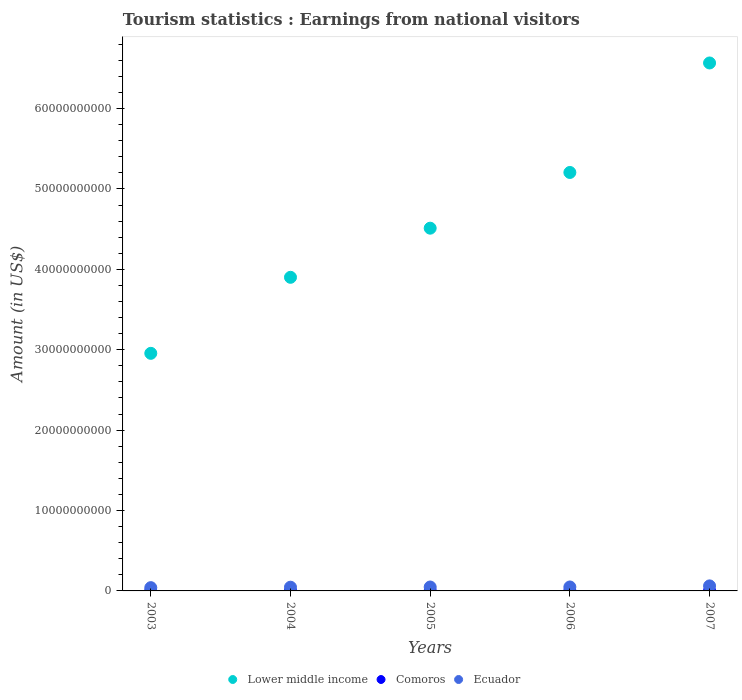How many different coloured dotlines are there?
Offer a very short reply. 3. Is the number of dotlines equal to the number of legend labels?
Provide a succinct answer. Yes. What is the earnings from national visitors in Comoros in 2005?
Keep it short and to the point. 2.44e+07. Across all years, what is the maximum earnings from national visitors in Comoros?
Offer a terse response. 3.04e+07. Across all years, what is the minimum earnings from national visitors in Ecuador?
Your answer should be compact. 4.08e+08. What is the total earnings from national visitors in Comoros in the graph?
Keep it short and to the point. 1.19e+08. What is the difference between the earnings from national visitors in Ecuador in 2004 and that in 2007?
Your answer should be very brief. -1.62e+08. What is the difference between the earnings from national visitors in Comoros in 2006 and the earnings from national visitors in Lower middle income in 2004?
Provide a short and direct response. -3.90e+1. What is the average earnings from national visitors in Lower middle income per year?
Keep it short and to the point. 4.63e+1. In the year 2005, what is the difference between the earnings from national visitors in Ecuador and earnings from national visitors in Lower middle income?
Ensure brevity in your answer.  -4.46e+1. What is the ratio of the earnings from national visitors in Comoros in 2003 to that in 2004?
Your response must be concise. 0.76. Is the earnings from national visitors in Comoros in 2003 less than that in 2006?
Provide a short and direct response. Yes. What is the difference between the highest and the second highest earnings from national visitors in Comoros?
Provide a short and direct response. 3.00e+06. What is the difference between the highest and the lowest earnings from national visitors in Lower middle income?
Ensure brevity in your answer.  3.61e+1. Is the sum of the earnings from national visitors in Ecuador in 2003 and 2004 greater than the maximum earnings from national visitors in Lower middle income across all years?
Make the answer very short. No. Is the earnings from national visitors in Lower middle income strictly less than the earnings from national visitors in Comoros over the years?
Ensure brevity in your answer.  No. How many dotlines are there?
Provide a succinct answer. 3. How many years are there in the graph?
Make the answer very short. 5. What is the difference between two consecutive major ticks on the Y-axis?
Give a very brief answer. 1.00e+1. Are the values on the major ticks of Y-axis written in scientific E-notation?
Keep it short and to the point. No. Does the graph contain any zero values?
Keep it short and to the point. No. Where does the legend appear in the graph?
Give a very brief answer. Bottom center. How are the legend labels stacked?
Offer a terse response. Horizontal. What is the title of the graph?
Ensure brevity in your answer.  Tourism statistics : Earnings from national visitors. What is the label or title of the Y-axis?
Your answer should be very brief. Amount (in US$). What is the Amount (in US$) of Lower middle income in 2003?
Ensure brevity in your answer.  2.96e+1. What is the Amount (in US$) in Comoros in 2003?
Keep it short and to the point. 1.60e+07. What is the Amount (in US$) in Ecuador in 2003?
Make the answer very short. 4.08e+08. What is the Amount (in US$) in Lower middle income in 2004?
Offer a terse response. 3.90e+1. What is the Amount (in US$) of Comoros in 2004?
Give a very brief answer. 2.10e+07. What is the Amount (in US$) in Ecuador in 2004?
Give a very brief answer. 4.64e+08. What is the Amount (in US$) of Lower middle income in 2005?
Ensure brevity in your answer.  4.51e+1. What is the Amount (in US$) in Comoros in 2005?
Offer a terse response. 2.44e+07. What is the Amount (in US$) in Ecuador in 2005?
Offer a terse response. 4.88e+08. What is the Amount (in US$) in Lower middle income in 2006?
Keep it short and to the point. 5.21e+1. What is the Amount (in US$) of Comoros in 2006?
Give a very brief answer. 2.74e+07. What is the Amount (in US$) in Ecuador in 2006?
Your answer should be very brief. 4.92e+08. What is the Amount (in US$) of Lower middle income in 2007?
Ensure brevity in your answer.  6.57e+1. What is the Amount (in US$) in Comoros in 2007?
Your response must be concise. 3.04e+07. What is the Amount (in US$) of Ecuador in 2007?
Keep it short and to the point. 6.26e+08. Across all years, what is the maximum Amount (in US$) of Lower middle income?
Provide a succinct answer. 6.57e+1. Across all years, what is the maximum Amount (in US$) in Comoros?
Your answer should be very brief. 3.04e+07. Across all years, what is the maximum Amount (in US$) of Ecuador?
Your response must be concise. 6.26e+08. Across all years, what is the minimum Amount (in US$) of Lower middle income?
Your answer should be very brief. 2.96e+1. Across all years, what is the minimum Amount (in US$) of Comoros?
Your answer should be very brief. 1.60e+07. Across all years, what is the minimum Amount (in US$) in Ecuador?
Provide a short and direct response. 4.08e+08. What is the total Amount (in US$) in Lower middle income in the graph?
Provide a succinct answer. 2.31e+11. What is the total Amount (in US$) in Comoros in the graph?
Your answer should be very brief. 1.19e+08. What is the total Amount (in US$) of Ecuador in the graph?
Keep it short and to the point. 2.48e+09. What is the difference between the Amount (in US$) in Lower middle income in 2003 and that in 2004?
Make the answer very short. -9.46e+09. What is the difference between the Amount (in US$) in Comoros in 2003 and that in 2004?
Provide a succinct answer. -5.00e+06. What is the difference between the Amount (in US$) of Ecuador in 2003 and that in 2004?
Your answer should be very brief. -5.60e+07. What is the difference between the Amount (in US$) of Lower middle income in 2003 and that in 2005?
Offer a terse response. -1.56e+1. What is the difference between the Amount (in US$) of Comoros in 2003 and that in 2005?
Keep it short and to the point. -8.40e+06. What is the difference between the Amount (in US$) of Ecuador in 2003 and that in 2005?
Give a very brief answer. -8.00e+07. What is the difference between the Amount (in US$) of Lower middle income in 2003 and that in 2006?
Offer a terse response. -2.25e+1. What is the difference between the Amount (in US$) of Comoros in 2003 and that in 2006?
Ensure brevity in your answer.  -1.14e+07. What is the difference between the Amount (in US$) in Ecuador in 2003 and that in 2006?
Make the answer very short. -8.40e+07. What is the difference between the Amount (in US$) of Lower middle income in 2003 and that in 2007?
Your answer should be very brief. -3.61e+1. What is the difference between the Amount (in US$) in Comoros in 2003 and that in 2007?
Your response must be concise. -1.44e+07. What is the difference between the Amount (in US$) in Ecuador in 2003 and that in 2007?
Offer a very short reply. -2.18e+08. What is the difference between the Amount (in US$) in Lower middle income in 2004 and that in 2005?
Offer a very short reply. -6.11e+09. What is the difference between the Amount (in US$) in Comoros in 2004 and that in 2005?
Give a very brief answer. -3.40e+06. What is the difference between the Amount (in US$) in Ecuador in 2004 and that in 2005?
Your answer should be compact. -2.40e+07. What is the difference between the Amount (in US$) of Lower middle income in 2004 and that in 2006?
Offer a very short reply. -1.30e+1. What is the difference between the Amount (in US$) of Comoros in 2004 and that in 2006?
Offer a terse response. -6.40e+06. What is the difference between the Amount (in US$) in Ecuador in 2004 and that in 2006?
Your answer should be very brief. -2.80e+07. What is the difference between the Amount (in US$) of Lower middle income in 2004 and that in 2007?
Ensure brevity in your answer.  -2.67e+1. What is the difference between the Amount (in US$) of Comoros in 2004 and that in 2007?
Provide a succinct answer. -9.40e+06. What is the difference between the Amount (in US$) in Ecuador in 2004 and that in 2007?
Offer a terse response. -1.62e+08. What is the difference between the Amount (in US$) in Lower middle income in 2005 and that in 2006?
Make the answer very short. -6.93e+09. What is the difference between the Amount (in US$) in Comoros in 2005 and that in 2006?
Offer a terse response. -3.00e+06. What is the difference between the Amount (in US$) of Ecuador in 2005 and that in 2006?
Provide a succinct answer. -4.00e+06. What is the difference between the Amount (in US$) in Lower middle income in 2005 and that in 2007?
Provide a short and direct response. -2.06e+1. What is the difference between the Amount (in US$) in Comoros in 2005 and that in 2007?
Your answer should be very brief. -6.00e+06. What is the difference between the Amount (in US$) of Ecuador in 2005 and that in 2007?
Your answer should be compact. -1.38e+08. What is the difference between the Amount (in US$) of Lower middle income in 2006 and that in 2007?
Ensure brevity in your answer.  -1.36e+1. What is the difference between the Amount (in US$) of Comoros in 2006 and that in 2007?
Give a very brief answer. -3.00e+06. What is the difference between the Amount (in US$) in Ecuador in 2006 and that in 2007?
Provide a succinct answer. -1.34e+08. What is the difference between the Amount (in US$) in Lower middle income in 2003 and the Amount (in US$) in Comoros in 2004?
Keep it short and to the point. 2.95e+1. What is the difference between the Amount (in US$) in Lower middle income in 2003 and the Amount (in US$) in Ecuador in 2004?
Provide a succinct answer. 2.91e+1. What is the difference between the Amount (in US$) in Comoros in 2003 and the Amount (in US$) in Ecuador in 2004?
Ensure brevity in your answer.  -4.48e+08. What is the difference between the Amount (in US$) of Lower middle income in 2003 and the Amount (in US$) of Comoros in 2005?
Give a very brief answer. 2.95e+1. What is the difference between the Amount (in US$) in Lower middle income in 2003 and the Amount (in US$) in Ecuador in 2005?
Keep it short and to the point. 2.91e+1. What is the difference between the Amount (in US$) of Comoros in 2003 and the Amount (in US$) of Ecuador in 2005?
Give a very brief answer. -4.72e+08. What is the difference between the Amount (in US$) of Lower middle income in 2003 and the Amount (in US$) of Comoros in 2006?
Keep it short and to the point. 2.95e+1. What is the difference between the Amount (in US$) in Lower middle income in 2003 and the Amount (in US$) in Ecuador in 2006?
Ensure brevity in your answer.  2.91e+1. What is the difference between the Amount (in US$) of Comoros in 2003 and the Amount (in US$) of Ecuador in 2006?
Provide a succinct answer. -4.76e+08. What is the difference between the Amount (in US$) of Lower middle income in 2003 and the Amount (in US$) of Comoros in 2007?
Give a very brief answer. 2.95e+1. What is the difference between the Amount (in US$) in Lower middle income in 2003 and the Amount (in US$) in Ecuador in 2007?
Offer a very short reply. 2.89e+1. What is the difference between the Amount (in US$) of Comoros in 2003 and the Amount (in US$) of Ecuador in 2007?
Offer a terse response. -6.10e+08. What is the difference between the Amount (in US$) in Lower middle income in 2004 and the Amount (in US$) in Comoros in 2005?
Your answer should be very brief. 3.90e+1. What is the difference between the Amount (in US$) of Lower middle income in 2004 and the Amount (in US$) of Ecuador in 2005?
Ensure brevity in your answer.  3.85e+1. What is the difference between the Amount (in US$) in Comoros in 2004 and the Amount (in US$) in Ecuador in 2005?
Provide a short and direct response. -4.67e+08. What is the difference between the Amount (in US$) in Lower middle income in 2004 and the Amount (in US$) in Comoros in 2006?
Your response must be concise. 3.90e+1. What is the difference between the Amount (in US$) of Lower middle income in 2004 and the Amount (in US$) of Ecuador in 2006?
Offer a terse response. 3.85e+1. What is the difference between the Amount (in US$) of Comoros in 2004 and the Amount (in US$) of Ecuador in 2006?
Offer a very short reply. -4.71e+08. What is the difference between the Amount (in US$) in Lower middle income in 2004 and the Amount (in US$) in Comoros in 2007?
Ensure brevity in your answer.  3.90e+1. What is the difference between the Amount (in US$) of Lower middle income in 2004 and the Amount (in US$) of Ecuador in 2007?
Provide a succinct answer. 3.84e+1. What is the difference between the Amount (in US$) of Comoros in 2004 and the Amount (in US$) of Ecuador in 2007?
Your response must be concise. -6.05e+08. What is the difference between the Amount (in US$) of Lower middle income in 2005 and the Amount (in US$) of Comoros in 2006?
Provide a short and direct response. 4.51e+1. What is the difference between the Amount (in US$) of Lower middle income in 2005 and the Amount (in US$) of Ecuador in 2006?
Provide a short and direct response. 4.46e+1. What is the difference between the Amount (in US$) of Comoros in 2005 and the Amount (in US$) of Ecuador in 2006?
Offer a terse response. -4.68e+08. What is the difference between the Amount (in US$) of Lower middle income in 2005 and the Amount (in US$) of Comoros in 2007?
Your answer should be very brief. 4.51e+1. What is the difference between the Amount (in US$) in Lower middle income in 2005 and the Amount (in US$) in Ecuador in 2007?
Offer a terse response. 4.45e+1. What is the difference between the Amount (in US$) of Comoros in 2005 and the Amount (in US$) of Ecuador in 2007?
Your response must be concise. -6.02e+08. What is the difference between the Amount (in US$) of Lower middle income in 2006 and the Amount (in US$) of Comoros in 2007?
Your response must be concise. 5.20e+1. What is the difference between the Amount (in US$) in Lower middle income in 2006 and the Amount (in US$) in Ecuador in 2007?
Ensure brevity in your answer.  5.14e+1. What is the difference between the Amount (in US$) of Comoros in 2006 and the Amount (in US$) of Ecuador in 2007?
Offer a very short reply. -5.99e+08. What is the average Amount (in US$) in Lower middle income per year?
Offer a very short reply. 4.63e+1. What is the average Amount (in US$) in Comoros per year?
Your response must be concise. 2.38e+07. What is the average Amount (in US$) of Ecuador per year?
Your response must be concise. 4.96e+08. In the year 2003, what is the difference between the Amount (in US$) of Lower middle income and Amount (in US$) of Comoros?
Give a very brief answer. 2.95e+1. In the year 2003, what is the difference between the Amount (in US$) in Lower middle income and Amount (in US$) in Ecuador?
Your answer should be very brief. 2.91e+1. In the year 2003, what is the difference between the Amount (in US$) of Comoros and Amount (in US$) of Ecuador?
Give a very brief answer. -3.92e+08. In the year 2004, what is the difference between the Amount (in US$) in Lower middle income and Amount (in US$) in Comoros?
Give a very brief answer. 3.90e+1. In the year 2004, what is the difference between the Amount (in US$) of Lower middle income and Amount (in US$) of Ecuador?
Ensure brevity in your answer.  3.86e+1. In the year 2004, what is the difference between the Amount (in US$) of Comoros and Amount (in US$) of Ecuador?
Provide a short and direct response. -4.43e+08. In the year 2005, what is the difference between the Amount (in US$) in Lower middle income and Amount (in US$) in Comoros?
Provide a short and direct response. 4.51e+1. In the year 2005, what is the difference between the Amount (in US$) of Lower middle income and Amount (in US$) of Ecuador?
Offer a terse response. 4.46e+1. In the year 2005, what is the difference between the Amount (in US$) of Comoros and Amount (in US$) of Ecuador?
Offer a very short reply. -4.64e+08. In the year 2006, what is the difference between the Amount (in US$) of Lower middle income and Amount (in US$) of Comoros?
Provide a short and direct response. 5.20e+1. In the year 2006, what is the difference between the Amount (in US$) of Lower middle income and Amount (in US$) of Ecuador?
Give a very brief answer. 5.16e+1. In the year 2006, what is the difference between the Amount (in US$) in Comoros and Amount (in US$) in Ecuador?
Provide a succinct answer. -4.65e+08. In the year 2007, what is the difference between the Amount (in US$) of Lower middle income and Amount (in US$) of Comoros?
Your answer should be compact. 6.56e+1. In the year 2007, what is the difference between the Amount (in US$) of Lower middle income and Amount (in US$) of Ecuador?
Ensure brevity in your answer.  6.51e+1. In the year 2007, what is the difference between the Amount (in US$) in Comoros and Amount (in US$) in Ecuador?
Your answer should be very brief. -5.96e+08. What is the ratio of the Amount (in US$) in Lower middle income in 2003 to that in 2004?
Provide a short and direct response. 0.76. What is the ratio of the Amount (in US$) of Comoros in 2003 to that in 2004?
Offer a very short reply. 0.76. What is the ratio of the Amount (in US$) of Ecuador in 2003 to that in 2004?
Ensure brevity in your answer.  0.88. What is the ratio of the Amount (in US$) in Lower middle income in 2003 to that in 2005?
Provide a succinct answer. 0.66. What is the ratio of the Amount (in US$) in Comoros in 2003 to that in 2005?
Keep it short and to the point. 0.66. What is the ratio of the Amount (in US$) in Ecuador in 2003 to that in 2005?
Provide a succinct answer. 0.84. What is the ratio of the Amount (in US$) of Lower middle income in 2003 to that in 2006?
Offer a terse response. 0.57. What is the ratio of the Amount (in US$) in Comoros in 2003 to that in 2006?
Make the answer very short. 0.58. What is the ratio of the Amount (in US$) in Ecuador in 2003 to that in 2006?
Provide a short and direct response. 0.83. What is the ratio of the Amount (in US$) in Lower middle income in 2003 to that in 2007?
Provide a succinct answer. 0.45. What is the ratio of the Amount (in US$) of Comoros in 2003 to that in 2007?
Offer a very short reply. 0.53. What is the ratio of the Amount (in US$) of Ecuador in 2003 to that in 2007?
Provide a succinct answer. 0.65. What is the ratio of the Amount (in US$) of Lower middle income in 2004 to that in 2005?
Provide a succinct answer. 0.86. What is the ratio of the Amount (in US$) in Comoros in 2004 to that in 2005?
Offer a terse response. 0.86. What is the ratio of the Amount (in US$) of Ecuador in 2004 to that in 2005?
Offer a very short reply. 0.95. What is the ratio of the Amount (in US$) in Lower middle income in 2004 to that in 2006?
Make the answer very short. 0.75. What is the ratio of the Amount (in US$) in Comoros in 2004 to that in 2006?
Make the answer very short. 0.77. What is the ratio of the Amount (in US$) in Ecuador in 2004 to that in 2006?
Make the answer very short. 0.94. What is the ratio of the Amount (in US$) of Lower middle income in 2004 to that in 2007?
Give a very brief answer. 0.59. What is the ratio of the Amount (in US$) in Comoros in 2004 to that in 2007?
Provide a succinct answer. 0.69. What is the ratio of the Amount (in US$) in Ecuador in 2004 to that in 2007?
Offer a very short reply. 0.74. What is the ratio of the Amount (in US$) of Lower middle income in 2005 to that in 2006?
Give a very brief answer. 0.87. What is the ratio of the Amount (in US$) in Comoros in 2005 to that in 2006?
Your response must be concise. 0.89. What is the ratio of the Amount (in US$) of Ecuador in 2005 to that in 2006?
Offer a terse response. 0.99. What is the ratio of the Amount (in US$) of Lower middle income in 2005 to that in 2007?
Your answer should be very brief. 0.69. What is the ratio of the Amount (in US$) of Comoros in 2005 to that in 2007?
Keep it short and to the point. 0.8. What is the ratio of the Amount (in US$) in Ecuador in 2005 to that in 2007?
Offer a terse response. 0.78. What is the ratio of the Amount (in US$) of Lower middle income in 2006 to that in 2007?
Offer a terse response. 0.79. What is the ratio of the Amount (in US$) of Comoros in 2006 to that in 2007?
Ensure brevity in your answer.  0.9. What is the ratio of the Amount (in US$) in Ecuador in 2006 to that in 2007?
Your answer should be very brief. 0.79. What is the difference between the highest and the second highest Amount (in US$) in Lower middle income?
Your answer should be very brief. 1.36e+1. What is the difference between the highest and the second highest Amount (in US$) of Comoros?
Ensure brevity in your answer.  3.00e+06. What is the difference between the highest and the second highest Amount (in US$) of Ecuador?
Your answer should be very brief. 1.34e+08. What is the difference between the highest and the lowest Amount (in US$) of Lower middle income?
Give a very brief answer. 3.61e+1. What is the difference between the highest and the lowest Amount (in US$) in Comoros?
Ensure brevity in your answer.  1.44e+07. What is the difference between the highest and the lowest Amount (in US$) of Ecuador?
Provide a short and direct response. 2.18e+08. 